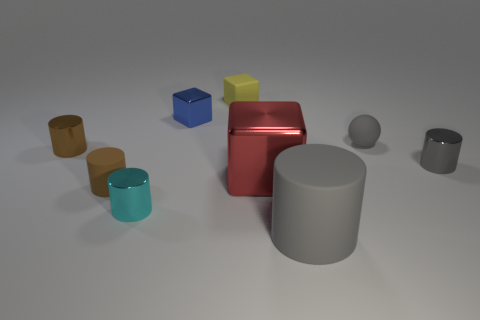Subtract all brown metallic cylinders. How many cylinders are left? 4 Subtract 1 blocks. How many blocks are left? 2 Subtract all blocks. How many objects are left? 6 Subtract all blue cubes. How many cubes are left? 2 Subtract all brown blocks. Subtract all green cylinders. How many blocks are left? 3 Subtract all purple cubes. How many cyan cylinders are left? 1 Subtract all large shiny blocks. Subtract all tiny red cubes. How many objects are left? 8 Add 6 cubes. How many cubes are left? 9 Add 3 large cyan matte cylinders. How many large cyan matte cylinders exist? 3 Subtract 1 cyan cylinders. How many objects are left? 8 